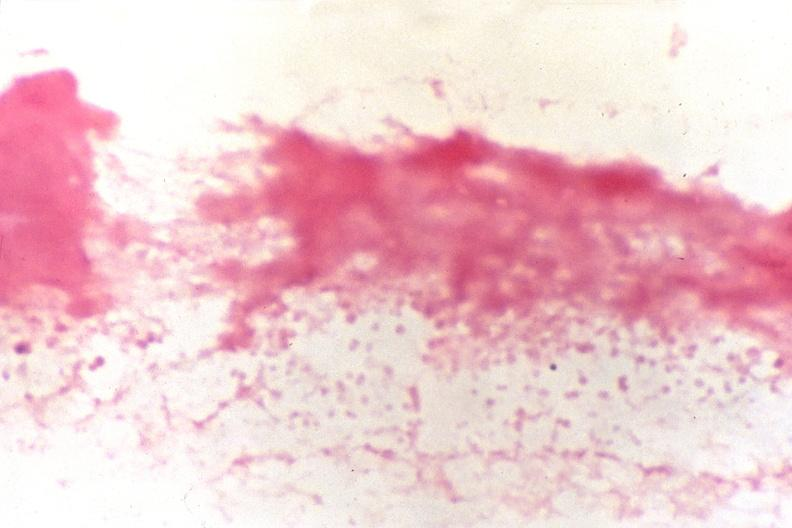what does this image show?
Answer the question using a single word or phrase. Cerebrospinal fluid 